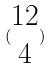Convert formula to latex. <formula><loc_0><loc_0><loc_500><loc_500>( \begin{matrix} 1 2 \\ 4 \end{matrix} )</formula> 